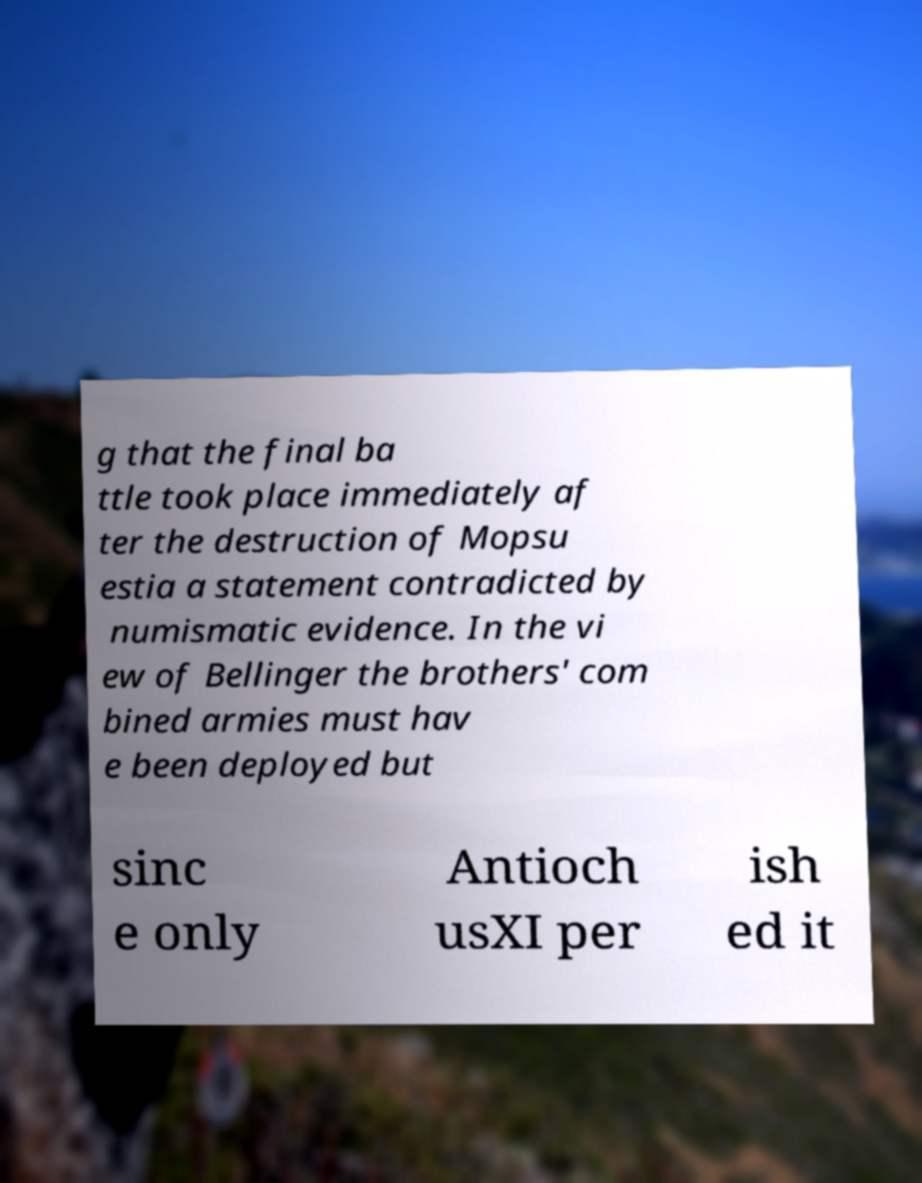Could you extract and type out the text from this image? g that the final ba ttle took place immediately af ter the destruction of Mopsu estia a statement contradicted by numismatic evidence. In the vi ew of Bellinger the brothers' com bined armies must hav e been deployed but sinc e only Antioch usXI per ish ed it 